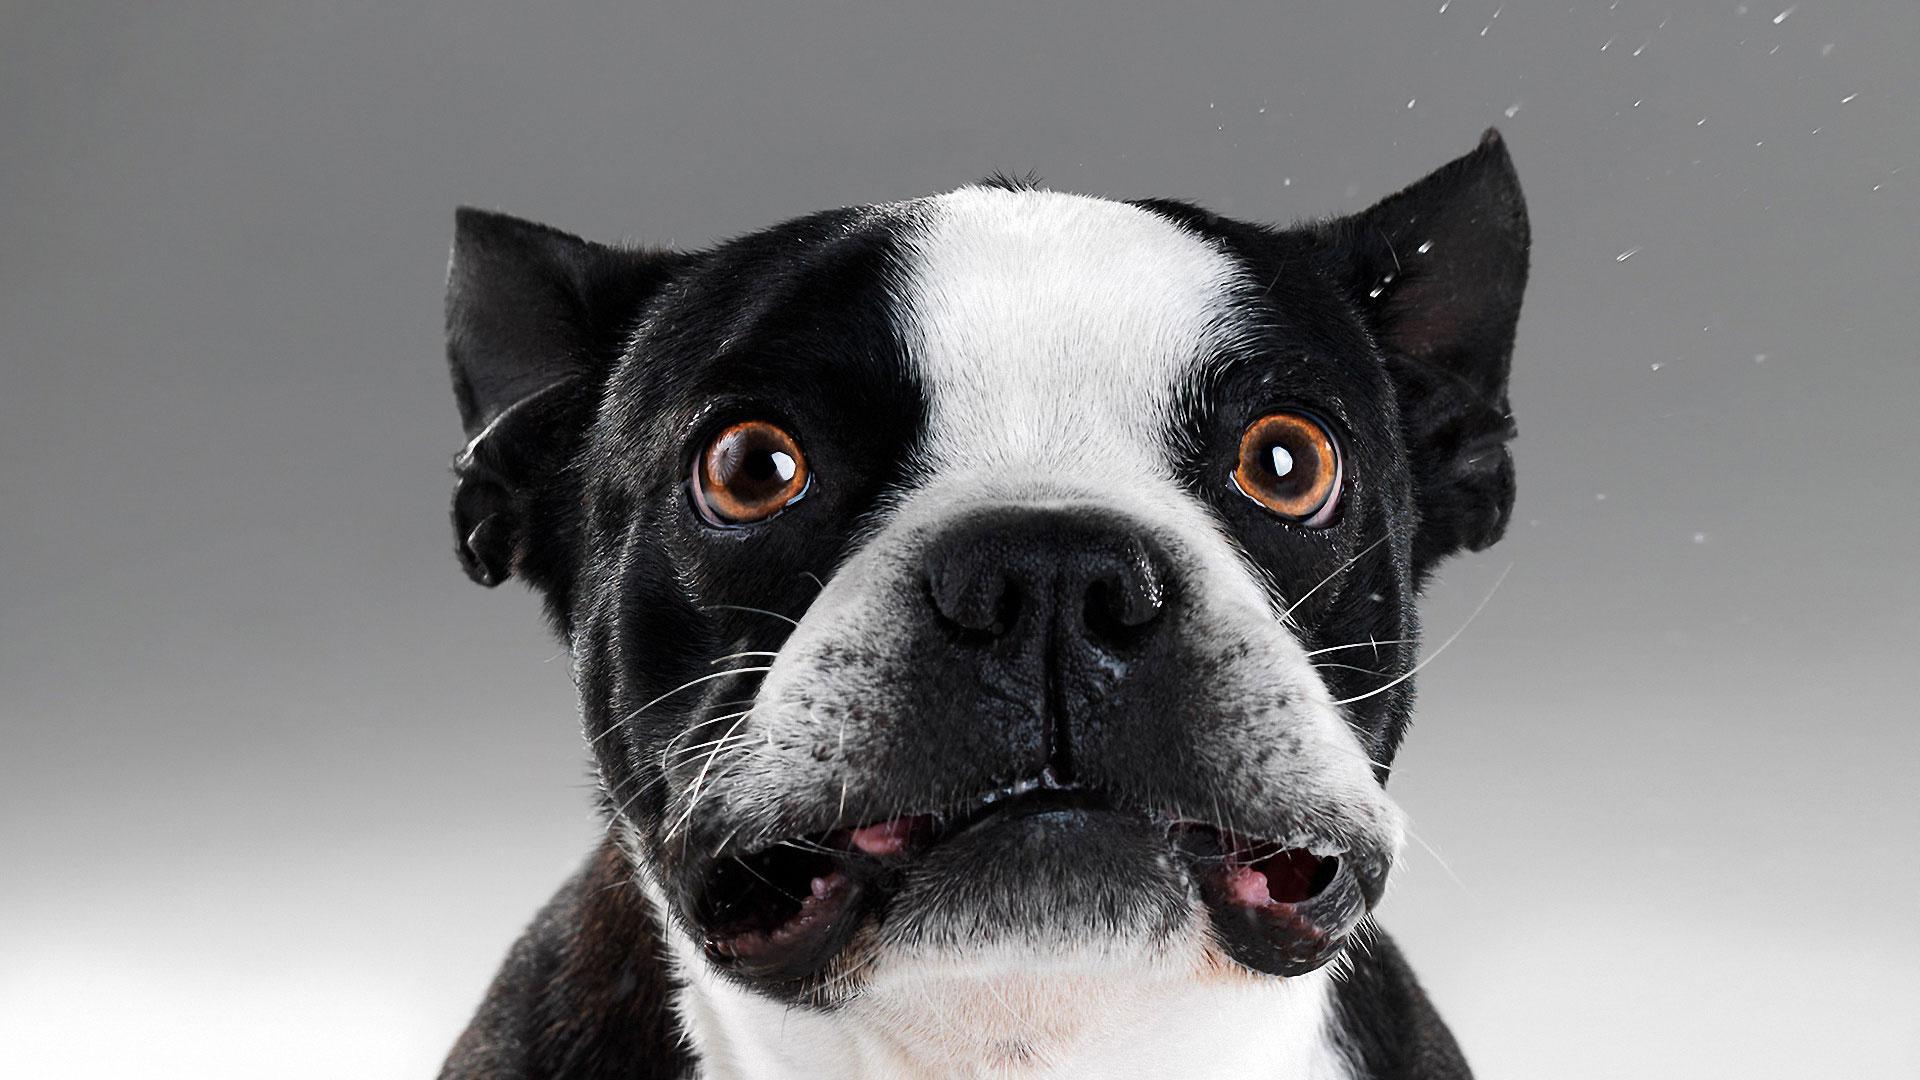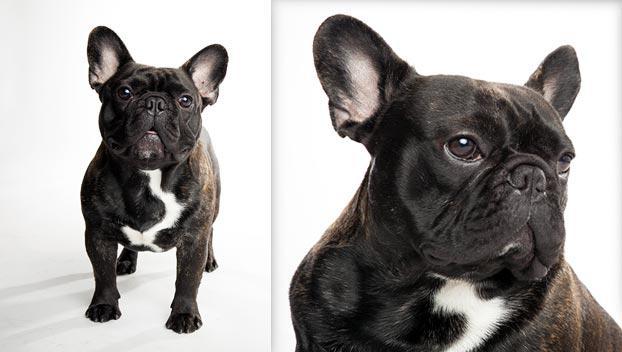The first image is the image on the left, the second image is the image on the right. For the images displayed, is the sentence "There are two young dogs." factually correct? Answer yes or no. No. 